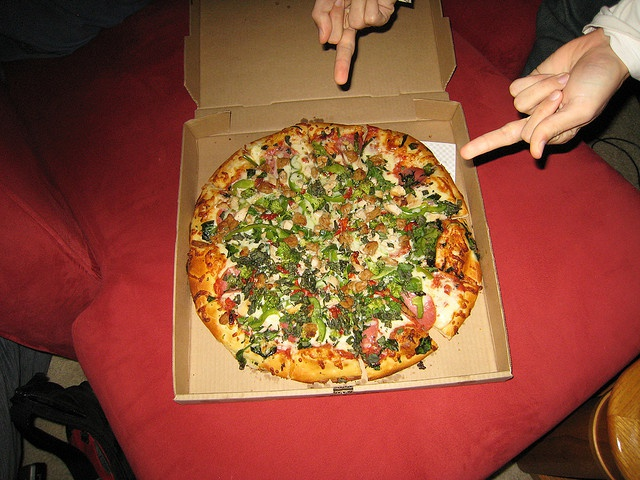Describe the objects in this image and their specific colors. I can see pizza in black, olive, brown, khaki, and tan tones, people in black and tan tones, handbag in black, maroon, and gray tones, broccoli in black, olive, and khaki tones, and broccoli in black, darkgreen, gray, and olive tones in this image. 